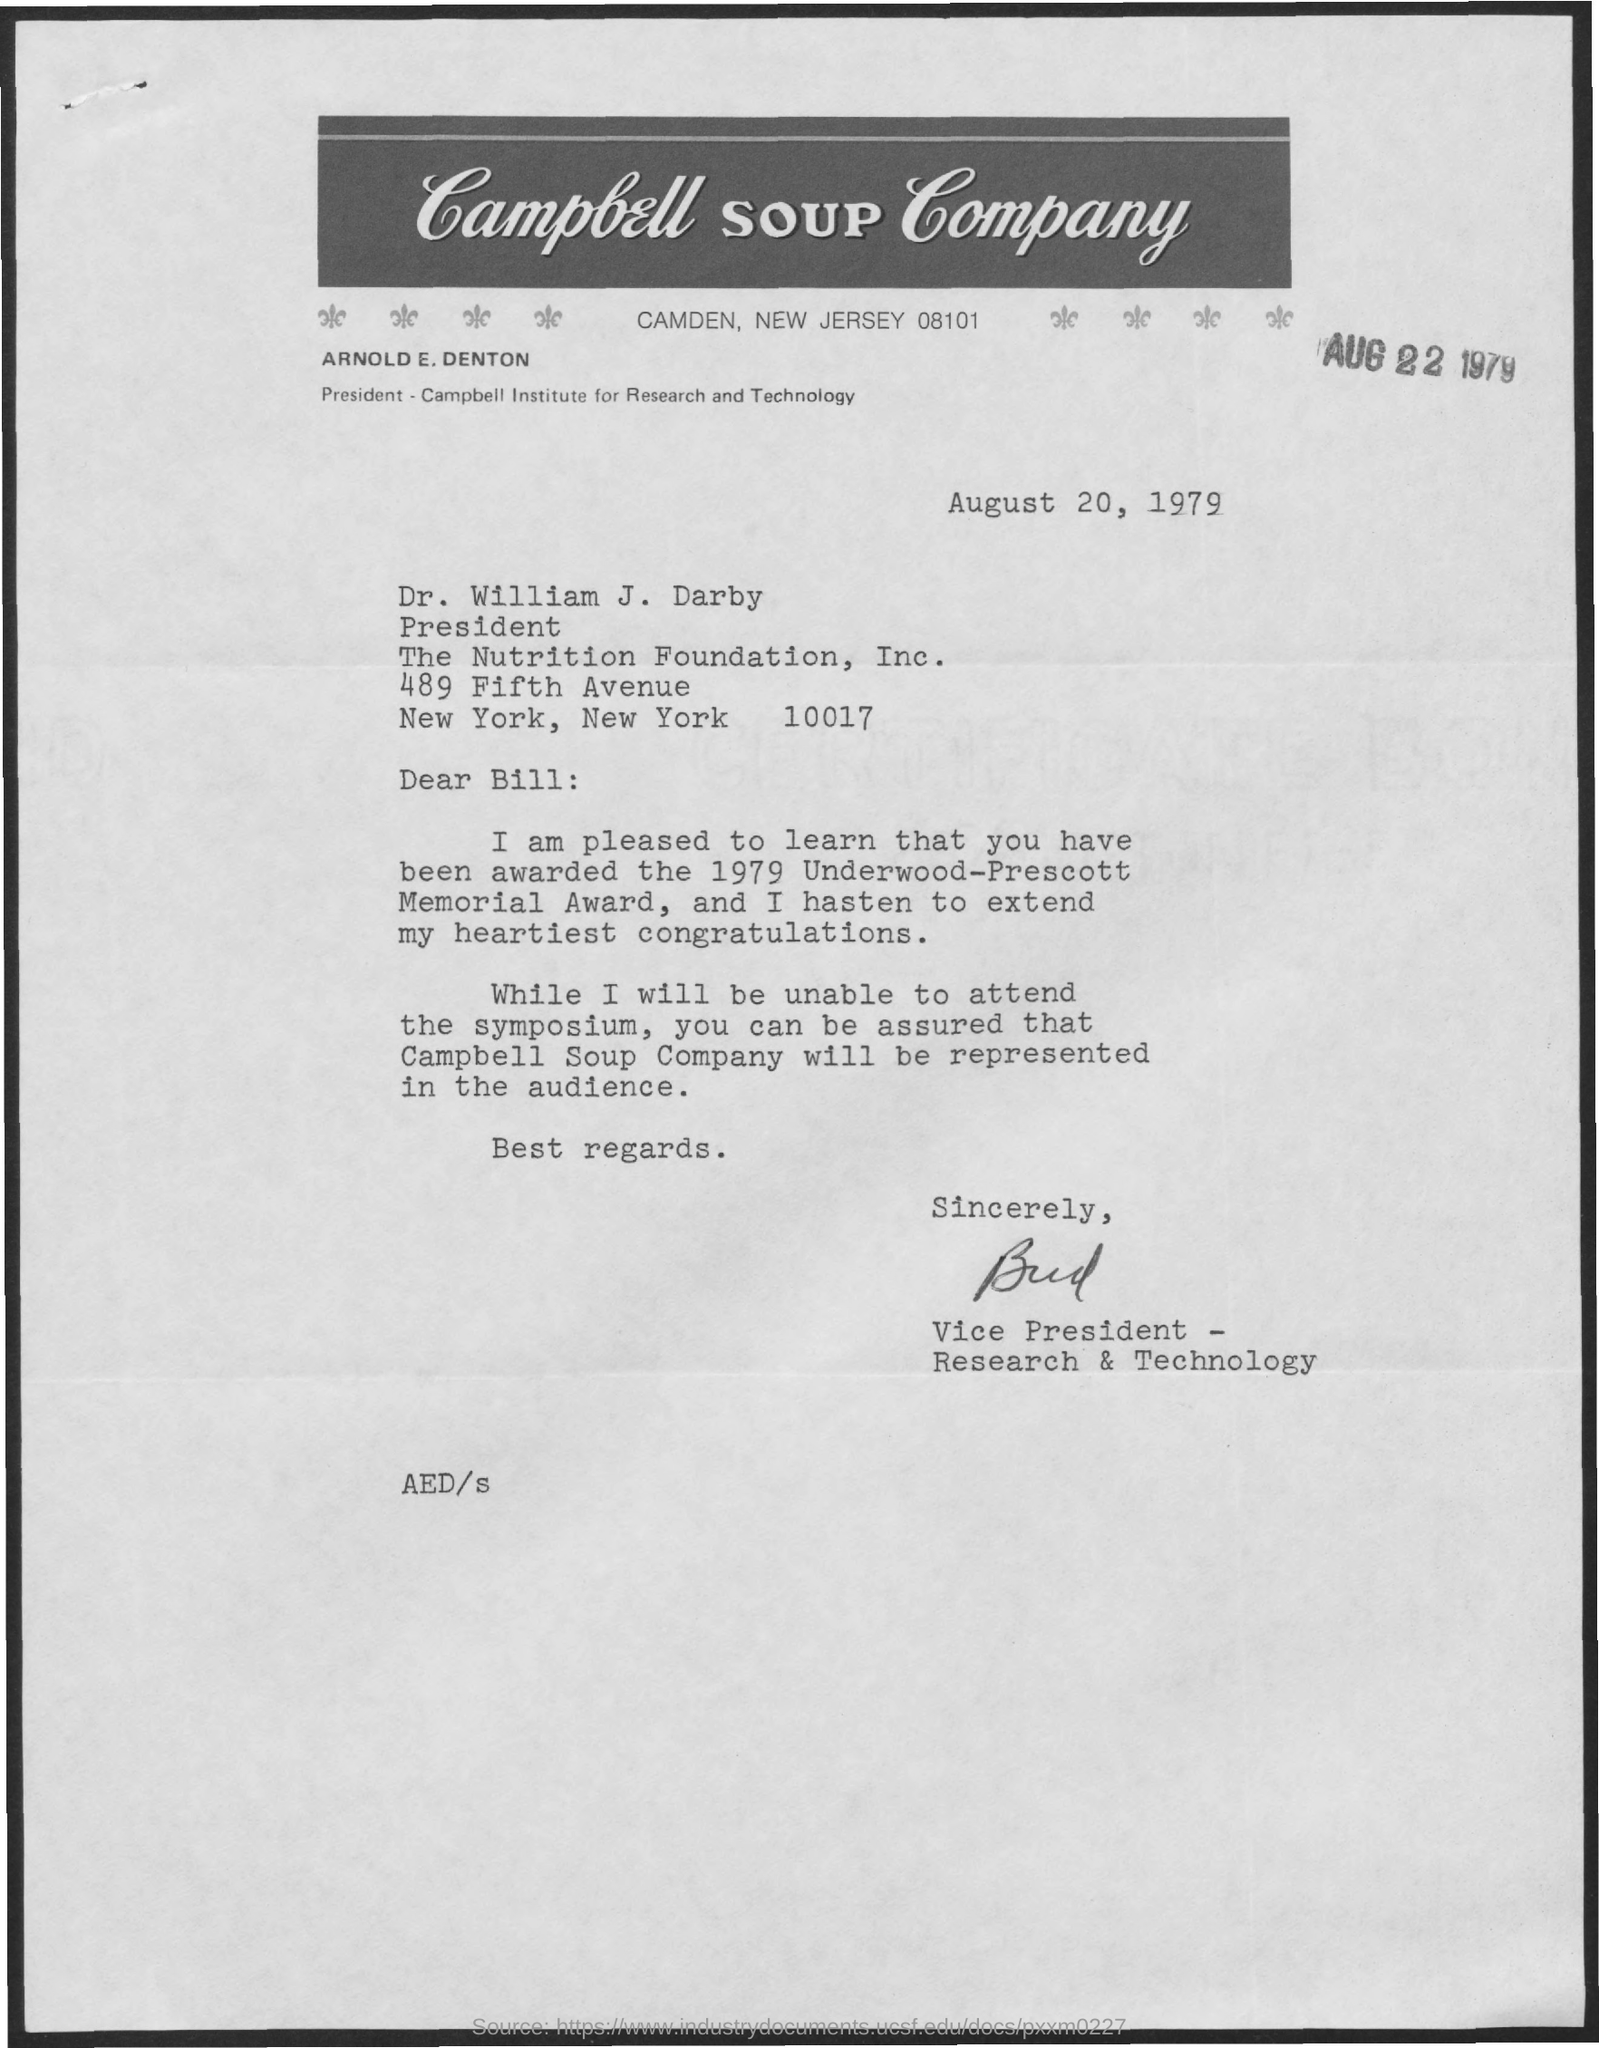Who is the president of Campbell Institute for Research and Technology?
Your response must be concise. ARNOLD E. DENTON. Which company is mentioned in the letter head?
Keep it short and to the point. Campbell SOUP Company. Who is the addressee of this letter?
Provide a short and direct response. Dr. William J. Darby. What is the designation of Dr. William J. Darby?
Offer a terse response. President, The Nutrition Foundation, Inc. Which award was won by Dr. William J. Darby in 1979?
Offer a very short reply. Underwood-Prescott Memorial Award. 